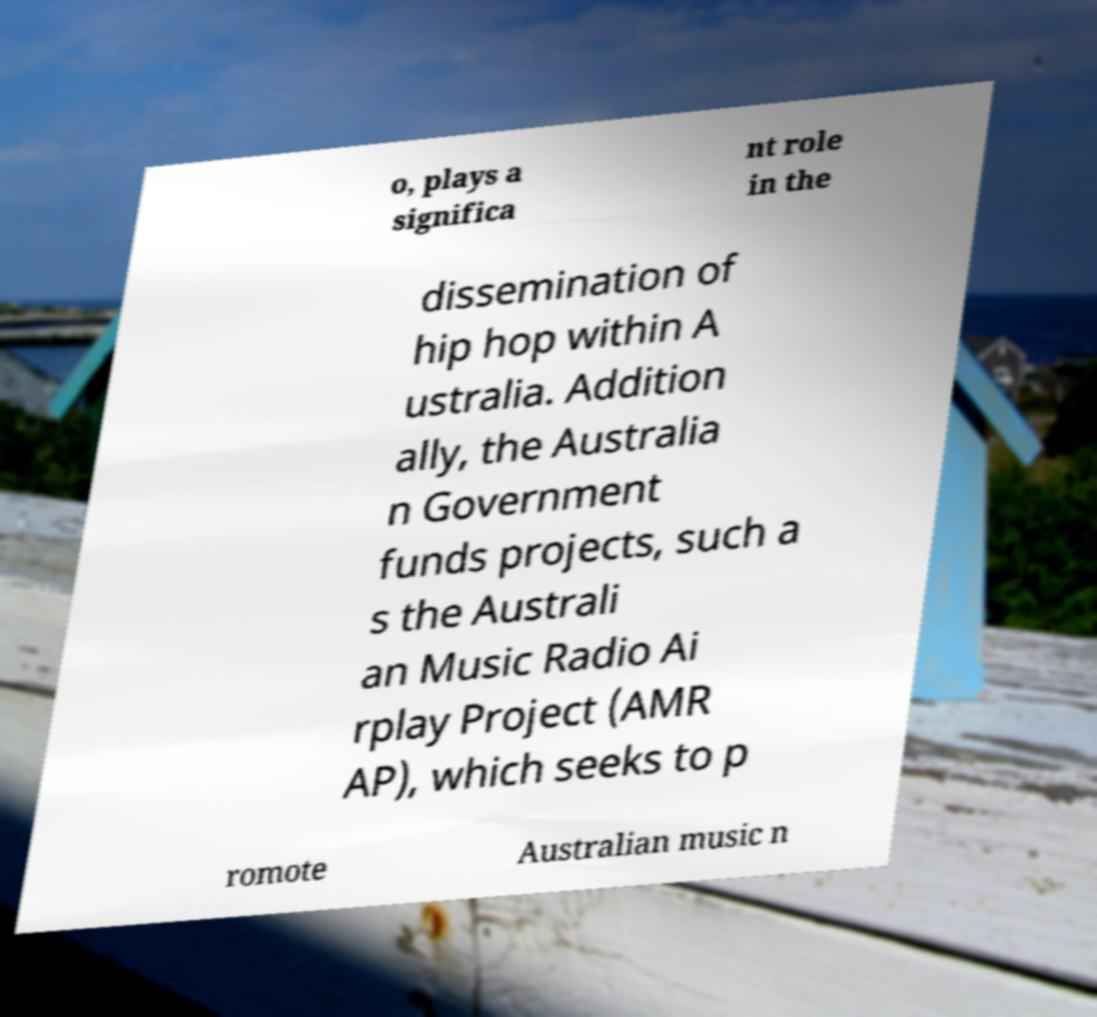Could you assist in decoding the text presented in this image and type it out clearly? o, plays a significa nt role in the dissemination of hip hop within A ustralia. Addition ally, the Australia n Government funds projects, such a s the Australi an Music Radio Ai rplay Project (AMR AP), which seeks to p romote Australian music n 